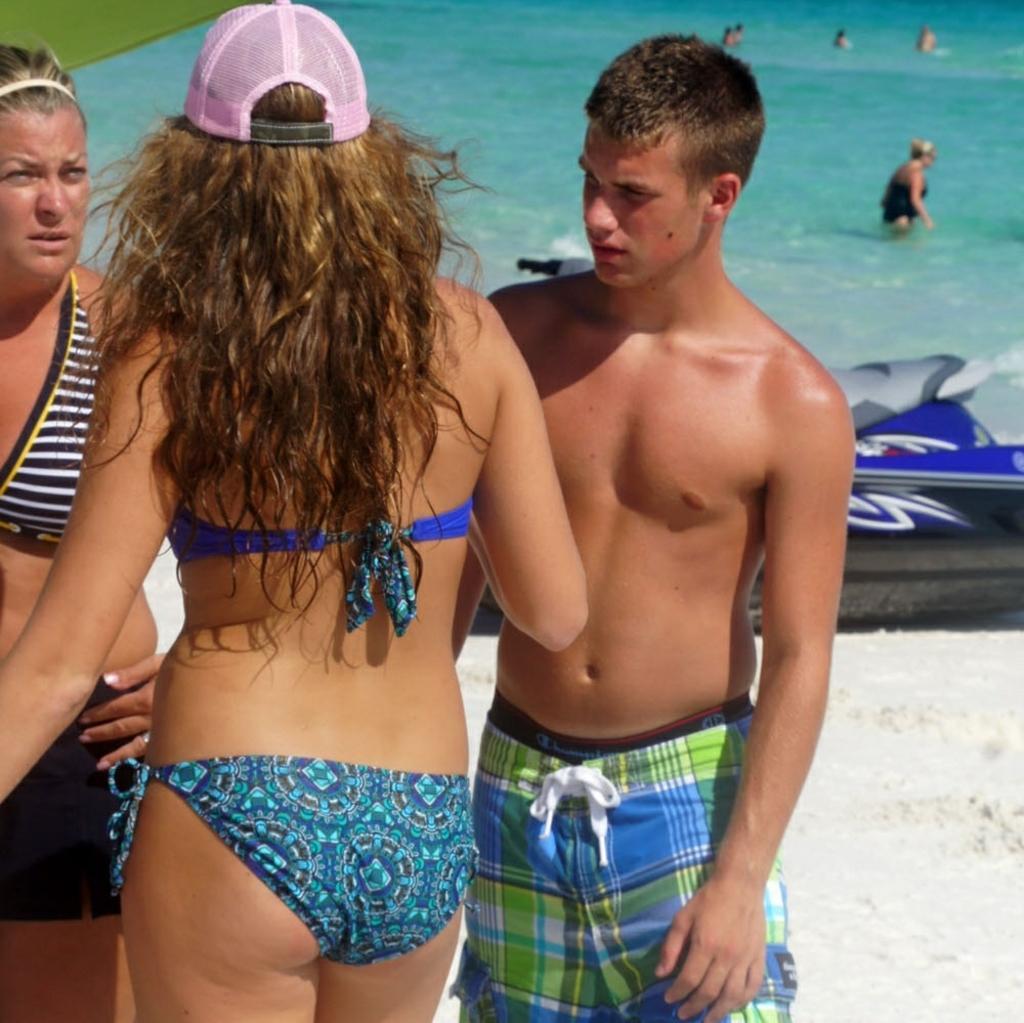Describe this image in one or two sentences. As we can see in the image there are few people here and there, swimming pool and grass. 